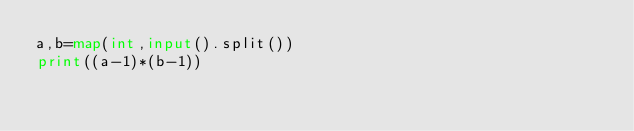<code> <loc_0><loc_0><loc_500><loc_500><_Python_>a,b=map(int,input().split())
print((a-1)*(b-1))</code> 